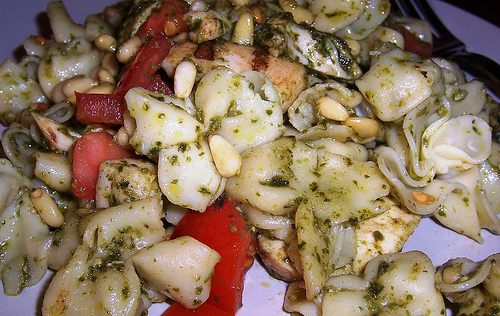<image>
Can you confirm if the pine nut is on the pepper? No. The pine nut is not positioned on the pepper. They may be near each other, but the pine nut is not supported by or resting on top of the pepper. 